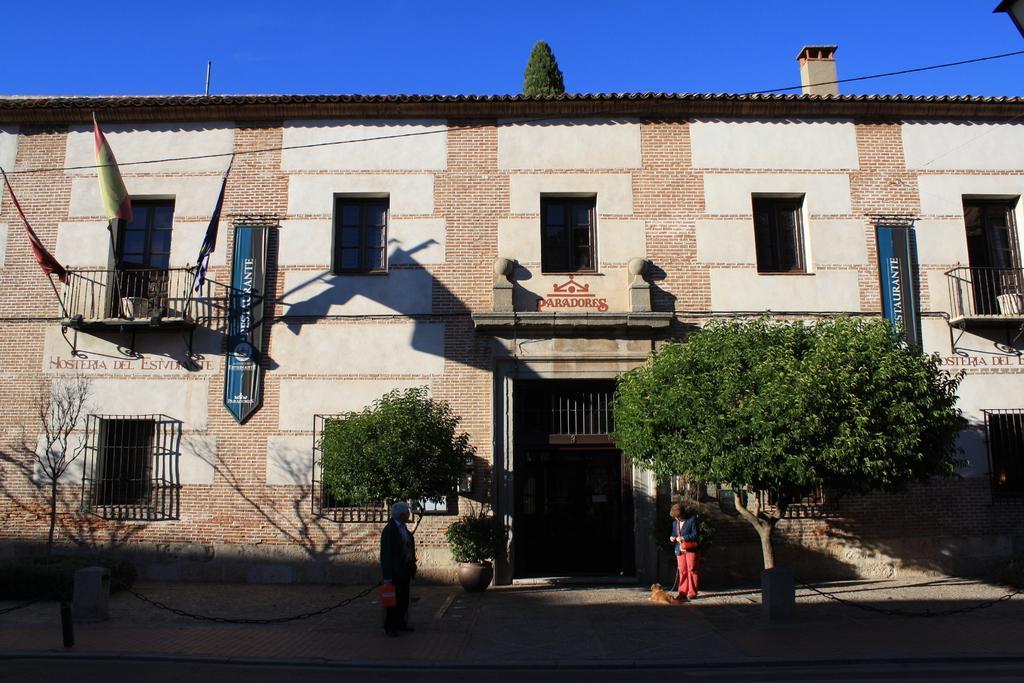Can you describe this image briefly? In this image there are two persons. A man with an orange color object and a woman wearing a bag and holding a dog. In the background there is a building and also trees and flags. There are small pillars on the path. Sky is visible at the top. 